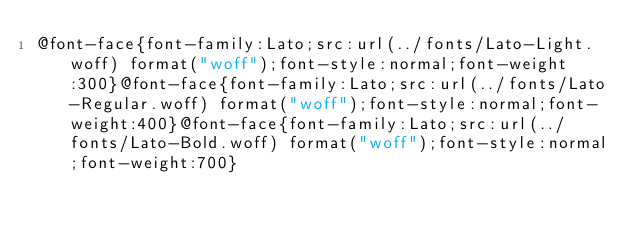Convert code to text. <code><loc_0><loc_0><loc_500><loc_500><_CSS_>@font-face{font-family:Lato;src:url(../fonts/Lato-Light.woff) format("woff");font-style:normal;font-weight:300}@font-face{font-family:Lato;src:url(../fonts/Lato-Regular.woff) format("woff");font-style:normal;font-weight:400}@font-face{font-family:Lato;src:url(../fonts/Lato-Bold.woff) format("woff");font-style:normal;font-weight:700}</code> 